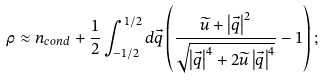<formula> <loc_0><loc_0><loc_500><loc_500>\rho \approx n _ { c o n d } + \frac { 1 } { 2 } \int _ { - 1 / 2 } ^ { 1 / 2 } d { \vec { q } } \left ( \frac { \widetilde { u } + \left | \vec { q } \right | ^ { 2 } } { \sqrt { \left | \vec { q } \right | ^ { 4 } + 2 \widetilde { u } \left | \vec { q } \right | ^ { 4 } } } - 1 \right ) ;</formula> 